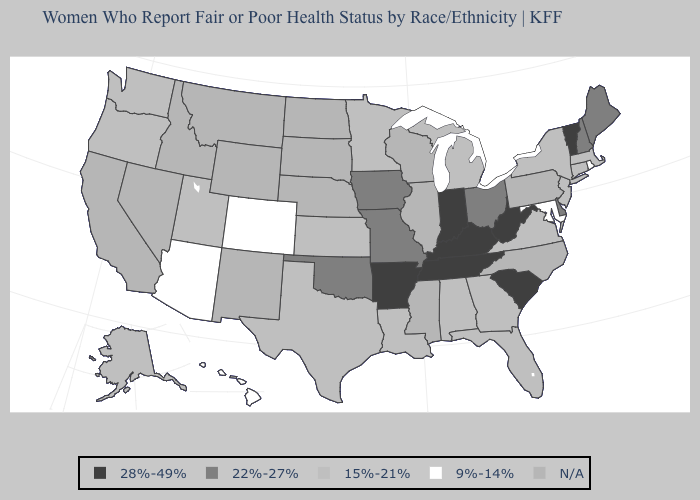What is the value of New Jersey?
Be succinct. 15%-21%. What is the lowest value in the USA?
Give a very brief answer. 9%-14%. Among the states that border South Carolina , which have the lowest value?
Answer briefly. Georgia. Does Delaware have the lowest value in the South?
Quick response, please. No. Name the states that have a value in the range 9%-14%?
Answer briefly. Arizona, Colorado, Hawaii, Maryland, Rhode Island. What is the lowest value in the West?
Write a very short answer. 9%-14%. What is the highest value in the West ?
Be succinct. 15%-21%. What is the lowest value in the USA?
Write a very short answer. 9%-14%. Name the states that have a value in the range N/A?
Keep it brief. California, Idaho, Illinois, Mississippi, Montana, Nebraska, Nevada, New Mexico, North Carolina, North Dakota, Pennsylvania, South Dakota, Wisconsin, Wyoming. Does Tennessee have the lowest value in the USA?
Short answer required. No. Name the states that have a value in the range 9%-14%?
Short answer required. Arizona, Colorado, Hawaii, Maryland, Rhode Island. Name the states that have a value in the range 9%-14%?
Answer briefly. Arizona, Colorado, Hawaii, Maryland, Rhode Island. Does Rhode Island have the lowest value in the USA?
Answer briefly. Yes. What is the value of Nevada?
Give a very brief answer. N/A. 